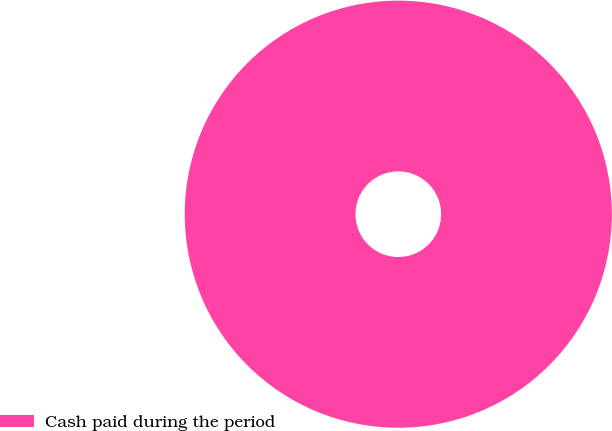Convert chart. <chart><loc_0><loc_0><loc_500><loc_500><pie_chart><fcel>Cash paid during the period<nl><fcel>100.0%<nl></chart> 